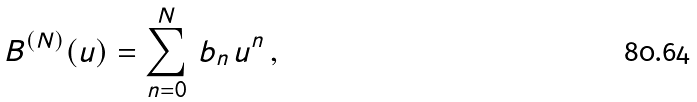Convert formula to latex. <formula><loc_0><loc_0><loc_500><loc_500>B ^ { ( N ) } ( u ) = \sum _ { n = 0 } ^ { N } \, b _ { n } \, u ^ { n } \, ,</formula> 